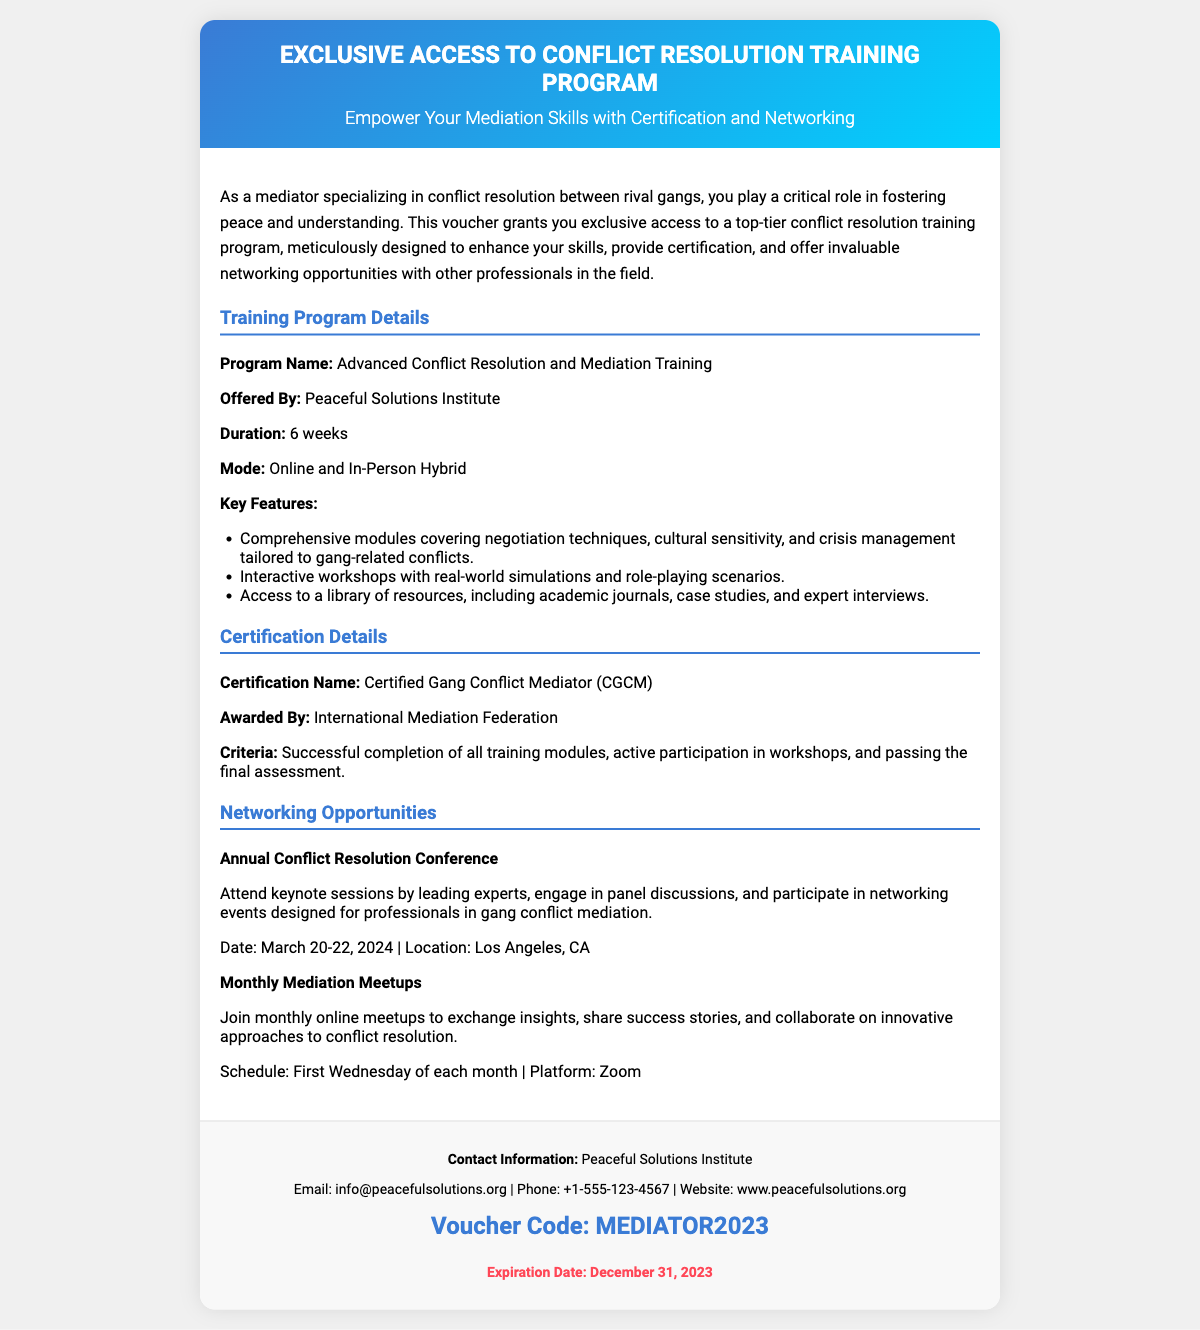What is the duration of the training program? The duration of the training program is mentioned in the details section of the document as 6 weeks.
Answer: 6 weeks What is the certification awarded upon completion? The certification awarded is specified in the certification details as Certified Gang Conflict Mediator (CGCM).
Answer: Certified Gang Conflict Mediator (CGCM) Who offers the training program? The organization offering the training program is identified in the details section as Peaceful Solutions Institute.
Answer: Peaceful Solutions Institute What is the location of the Annual Conflict Resolution Conference? The location for the conference is provided in the networking opportunities section as Los Angeles, CA.
Answer: Los Angeles, CA What is the voucher code presented in the document? The voucher code is found in the footer, which is stated as MEDIATOR2023.
Answer: MEDIATOR2023 What is the criteria for certification? The criteria are mentioned in the certification details and include successful completion of training modules, active participation, and passing the final assessment.
Answer: Successful completion of all training modules, active participation in workshops, and passing the final assessment What is the frequency of the Monthly Mediation Meetups? The frequency of the meetups is mentioned and specified as the first Wednesday of each month.
Answer: First Wednesday of each month What is the email contact for the Peaceful Solutions Institute? The email contact is found in the footer section of the document, listed as info@peacefulsolutions.org.
Answer: info@peacefulsolutions.org What year does the voucher expire? The expiration year is explicitly indicated in the document as 2023.
Answer: 2023 